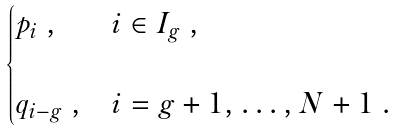<formula> <loc_0><loc_0><loc_500><loc_500>\begin{cases} p _ { i } \ , & i \in I _ { g } \ , \\ & \\ q _ { i - g } \ , & i = g + 1 , \dots , N + 1 \ . \end{cases}</formula> 